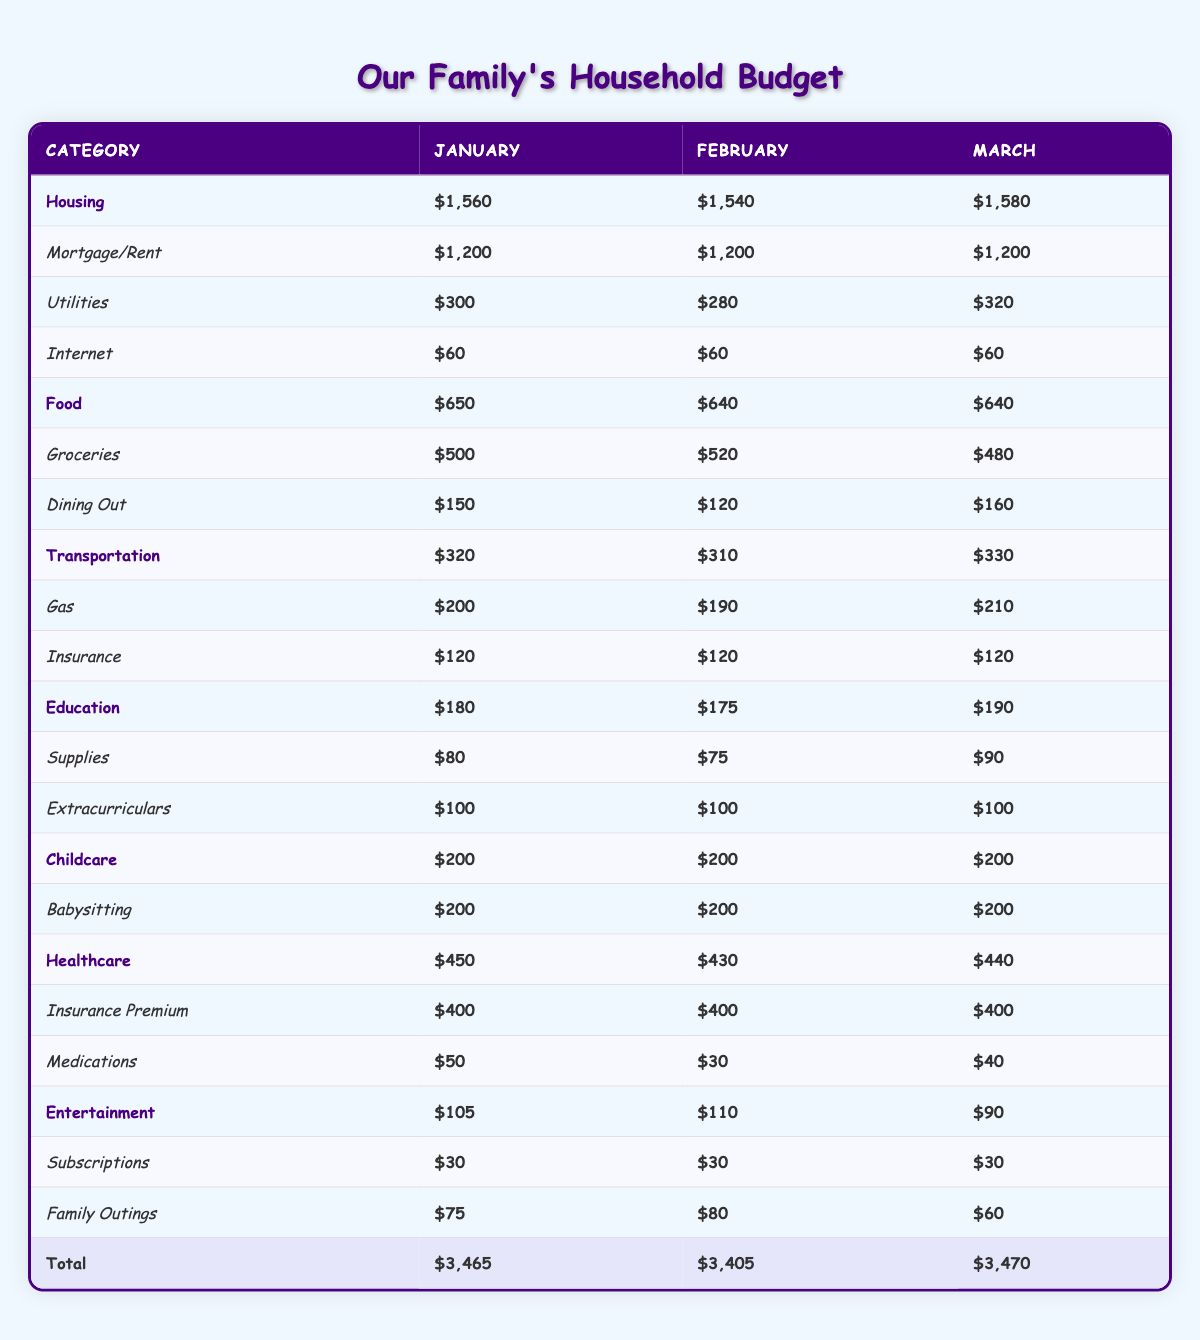What is the total transportation cost for January? In January, the transportation costs are Gas ($200) and Insurance ($120). To find the total, we add these two amounts: 200 + 120 = 320.
Answer: 320 How much did we spend on healthcare in February? In February, the healthcare costs are Insurance Premium ($400) and Medications ($30). Adding these gives 400 + 30 = 430.
Answer: 430 Was the total education expense in March higher than in January? The total education expense in March is $190, while in January, it's $180. Since 190 > 180, the statement is true.
Answer: Yes What was the difference in food expenses between January and February? In January, the food expenses total $650, whereas in February, they total $640. The difference is calculated as 650 - 640 = 10.
Answer: 10 What is the average monthly expenditure for housing over the three months? For housing, the total costs are January ($1,560), February ($1,540), and March ($1,580). Summing these gives 1,560 + 1,540 + 1,580 = 4,680. To find the average, divide by 3: 4,680 / 3 = 1,560.
Answer: 1,560 Did our family reduce dining out expenses from January to February? In January, dining out expenses were $150, and in February, they were $120. Since 150 > 120, the family did reduce dining out expenses.
Answer: Yes What is the total amount spent on childcare for the three months? Childcare expenses across the three months are constant at $200 for each month. Therefore, the total is 200 + 200 + 200 = 600.
Answer: 600 Which month had the highest total entertainment cost? The entertainment costs are: January ($105), February ($110), and March ($90). Since $110 in February is higher than the other two months, February had the highest total.
Answer: February What was the greatest decrease in any single category from January to February? Looking at each category's values shows Utilities decreased from $300 in January to $280 in February. The decrease of 300 - 280 = 20 is the greatest.
Answer: 20 